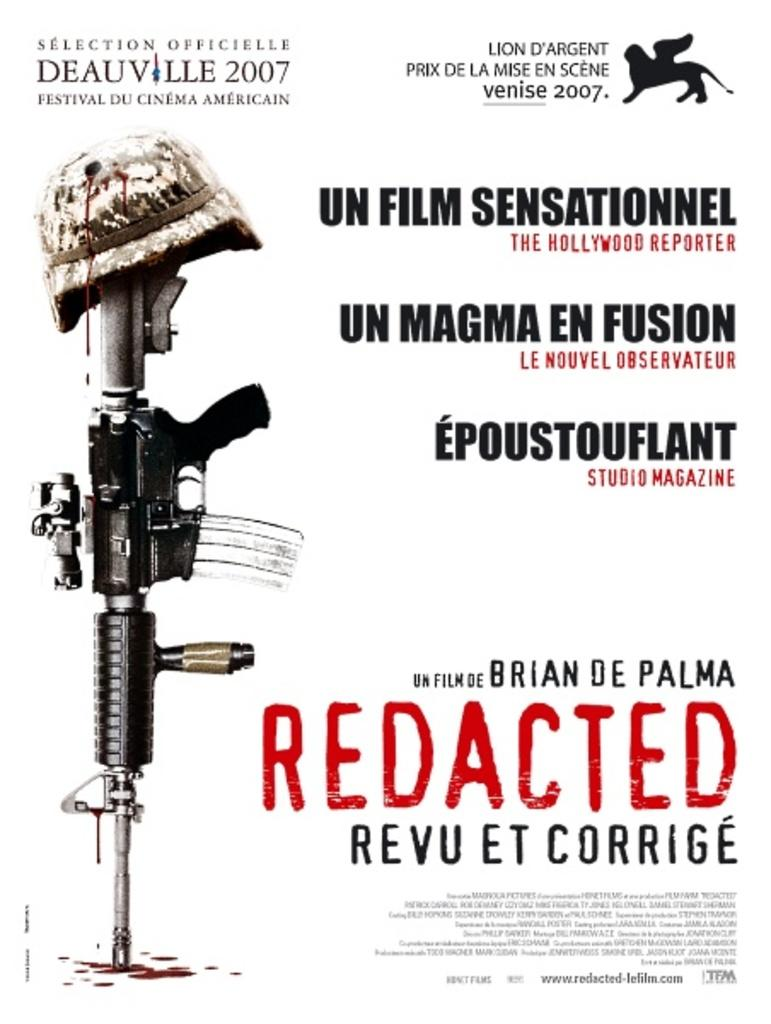What type of visual is the image? The image is a poster. What can be found on the poster besides the visual elements? There is text on the poster. What are the two main images depicted on the poster? There is a picture of a gun and a picture of a cap on the poster. How many spiders are crawling on the gun in the image? There are no spiders present in the image; it only features a picture of a gun and a cap. Can you describe the girl in the image? There is no girl depicted in the image; it only features a picture of a gun and a cap. 